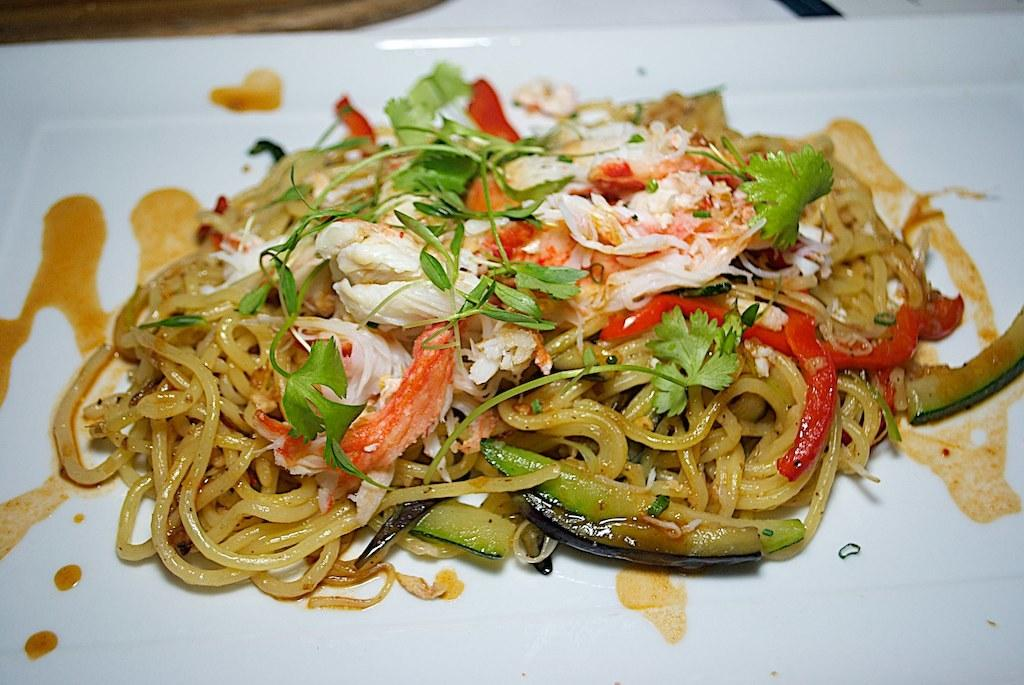What is the main subject of the image? There is a food item on a plate in the image. How many lizards can be seen playing in the schoolyard in the image? There are no lizards or schoolyard present in the image; it features a food item on a plate. 